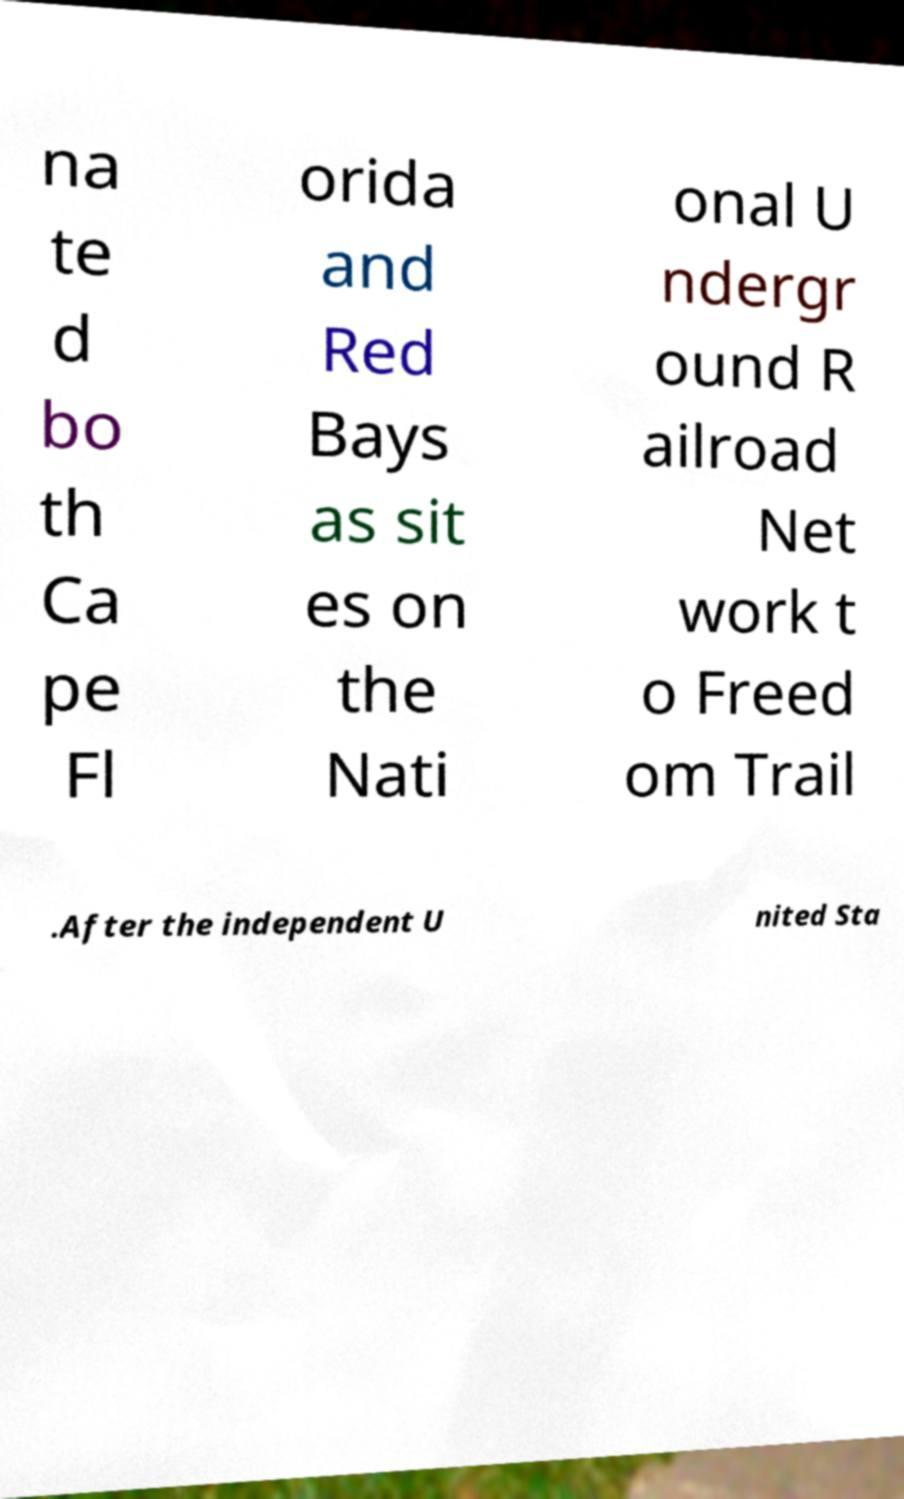Please identify and transcribe the text found in this image. na te d bo th Ca pe Fl orida and Red Bays as sit es on the Nati onal U ndergr ound R ailroad Net work t o Freed om Trail .After the independent U nited Sta 